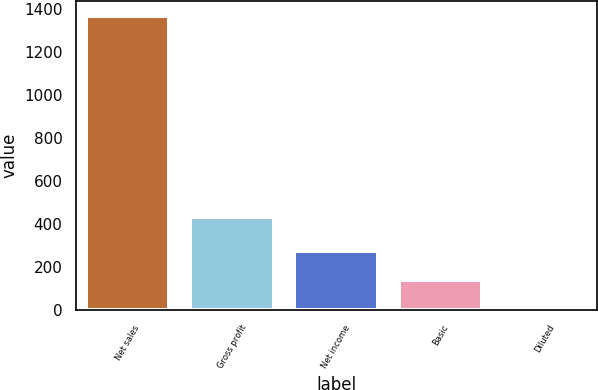Convert chart to OTSL. <chart><loc_0><loc_0><loc_500><loc_500><bar_chart><fcel>Net sales<fcel>Gross profit<fcel>Net income<fcel>Basic<fcel>Diluted<nl><fcel>1368.4<fcel>434.7<fcel>274.93<fcel>138.25<fcel>1.57<nl></chart> 